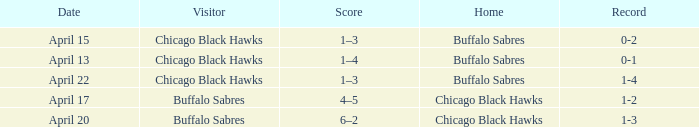When has a Record of 1-3? April 20. 